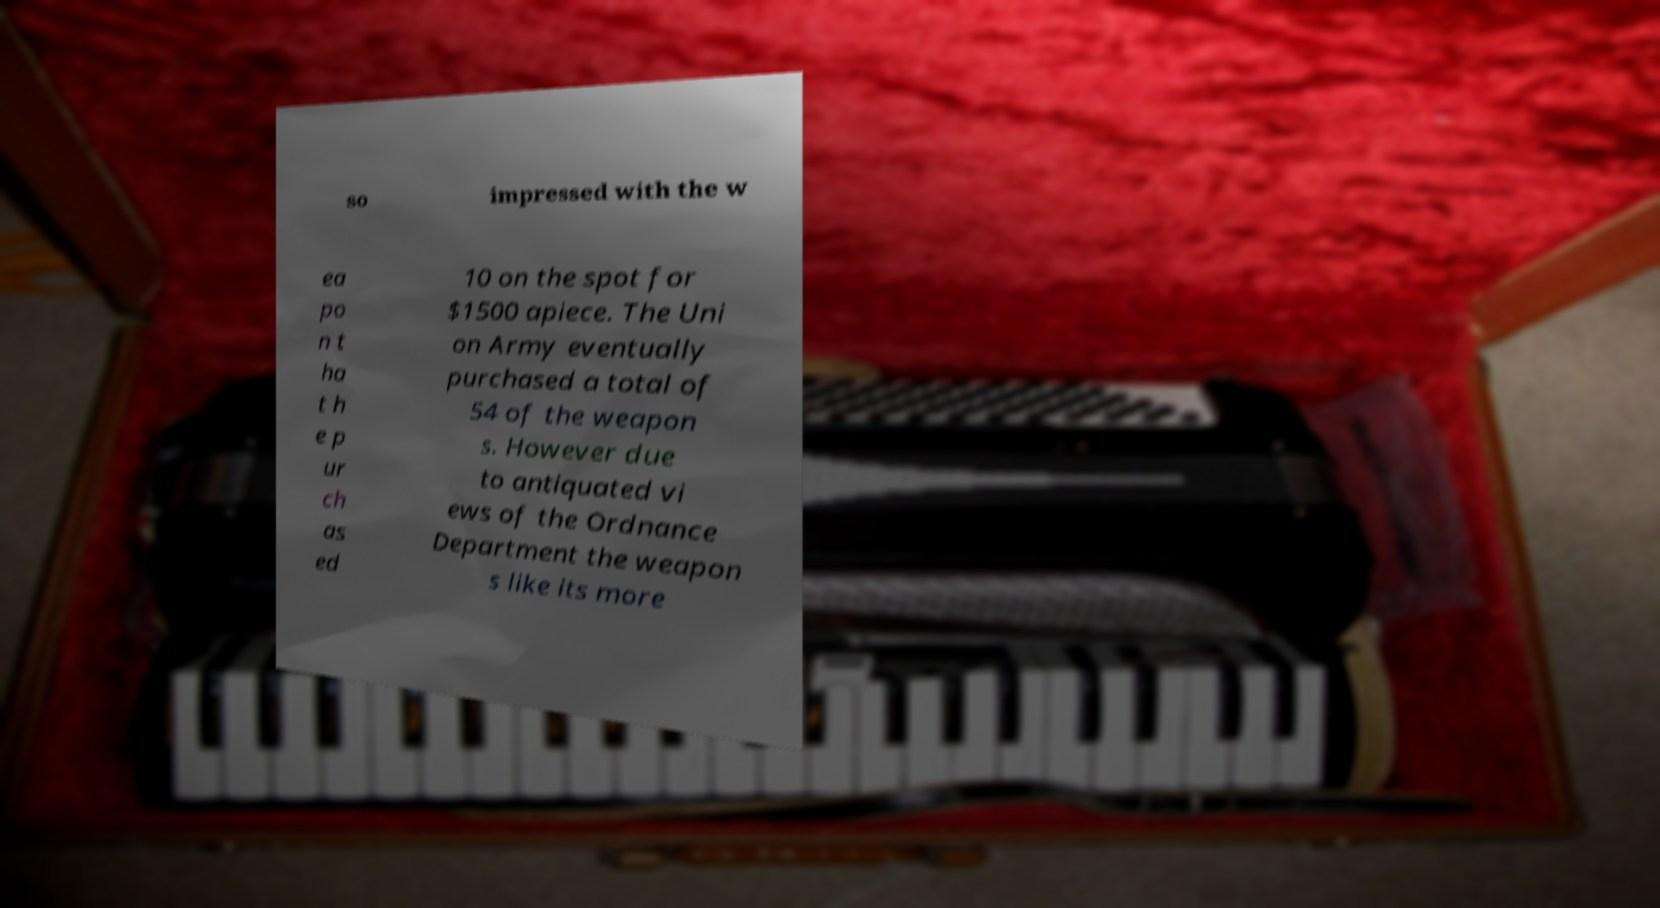There's text embedded in this image that I need extracted. Can you transcribe it verbatim? so impressed with the w ea po n t ha t h e p ur ch as ed 10 on the spot for $1500 apiece. The Uni on Army eventually purchased a total of 54 of the weapon s. However due to antiquated vi ews of the Ordnance Department the weapon s like its more 